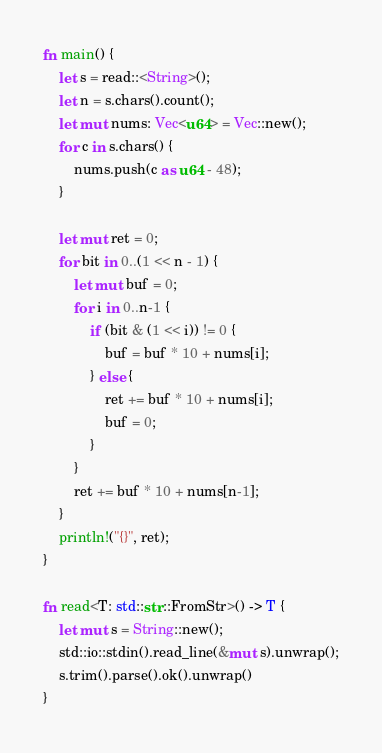<code> <loc_0><loc_0><loc_500><loc_500><_Rust_>fn main() {
    let s = read::<String>();
    let n = s.chars().count();
    let mut nums: Vec<u64> = Vec::new();
    for c in s.chars() {
        nums.push(c as u64 - 48);
    }

    let mut ret = 0;
    for bit in 0..(1 << n - 1) {
        let mut buf = 0;
        for i in 0..n-1 {
            if (bit & (1 << i)) != 0 {
                buf = buf * 10 + nums[i];
            } else {
                ret += buf * 10 + nums[i];
                buf = 0;
            }
        }
        ret += buf * 10 + nums[n-1];
    }
    println!("{}", ret);
}

fn read<T: std::str::FromStr>() -> T {
    let mut s = String::new();
    std::io::stdin().read_line(&mut s).unwrap();
    s.trim().parse().ok().unwrap()
}</code> 